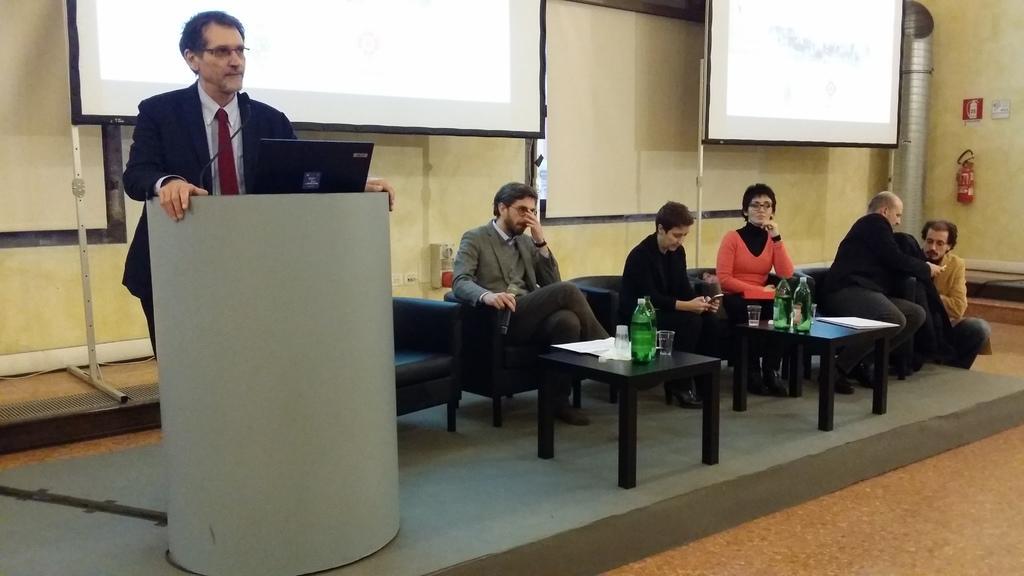Describe this image in one or two sentences. In the image we can see there is a man who is standing and in front of him there is a podium on which there is a laptop kept and there are people who are sitting on chairs. 